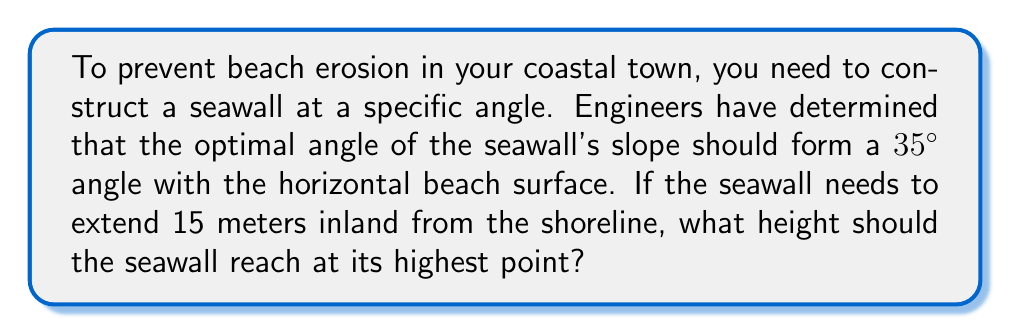What is the answer to this math problem? To solve this problem, we can use basic trigonometry. We have a right triangle where:

- The angle between the beach (horizontal) and the seawall is 35°
- The adjacent side (distance inland) is 15 meters
- We need to find the opposite side (height of the seawall)

We can use the tangent function to solve for the height:

$$\tan(\theta) = \frac{\text{opposite}}{\text{adjacent}}$$

Rearranging this, we get:

$$\text{opposite} = \text{adjacent} \times \tan(\theta)$$

Plugging in our known values:

$$\text{height} = 15 \times \tan(35°)$$

Using a calculator or trigonometric table:

$$\text{height} = 15 \times 0.7002$$

$$\text{height} = 10.503 \text{ meters}$$

[asy]
import geometry;

size(200);
pair A=(0,0), B=(15,0), C=(15,10.503);
draw(A--B--C--A);
draw(rightanglemark(A,B,C,8));
label("15 m", (B-A)/2, S);
label("10.503 m", (C-B)/2, E);
label("35°", A, SW);
label("Beach", (B-A)/2, N);
label("Seawall", (C-A)/2, NW);
[/asy]

Rounding to two decimal places for practical construction purposes:

$$\text{height} \approx 10.50 \text{ meters}$$
Answer: The seawall should reach a height of approximately 10.50 meters at its highest point. 